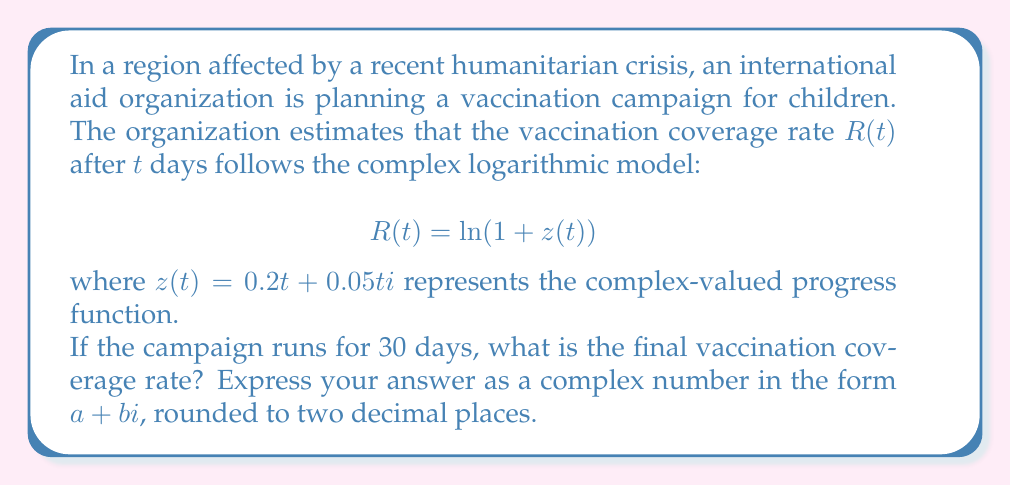Can you solve this math problem? To solve this problem, we need to follow these steps:

1) First, we need to calculate $z(30)$:
   $$z(30) = 0.2(30) + 0.05(30)i = 6 + 1.5i$$

2) Now, we need to calculate $R(30) = \ln(1 + z(30))$:
   $$R(30) = \ln(1 + 6 + 1.5i) = \ln(7 + 1.5i)$$

3) To calculate the complex logarithm, we use the formula:
   $$\ln(x + yi) = \ln(\sqrt{x^2 + y^2}) + i\arctan(\frac{y}{x})$$

4) Let's calculate each part:
   $$\sqrt{x^2 + y^2} = \sqrt{7^2 + 1.5^2} = \sqrt{51.25} \approx 7.1589$$
   $$\arctan(\frac{y}{x}) = \arctan(\frac{1.5}{7}) \approx 0.2112$$

5) Therefore:
   $$R(30) = \ln(7.1589) + 0.2112i$$

6) Calculate $\ln(7.1589)$:
   $$\ln(7.1589) \approx 1.9684$$

7) The final result is:
   $$R(30) \approx 1.9684 + 0.2112i$$
Answer: $1.97 + 0.21i$ 